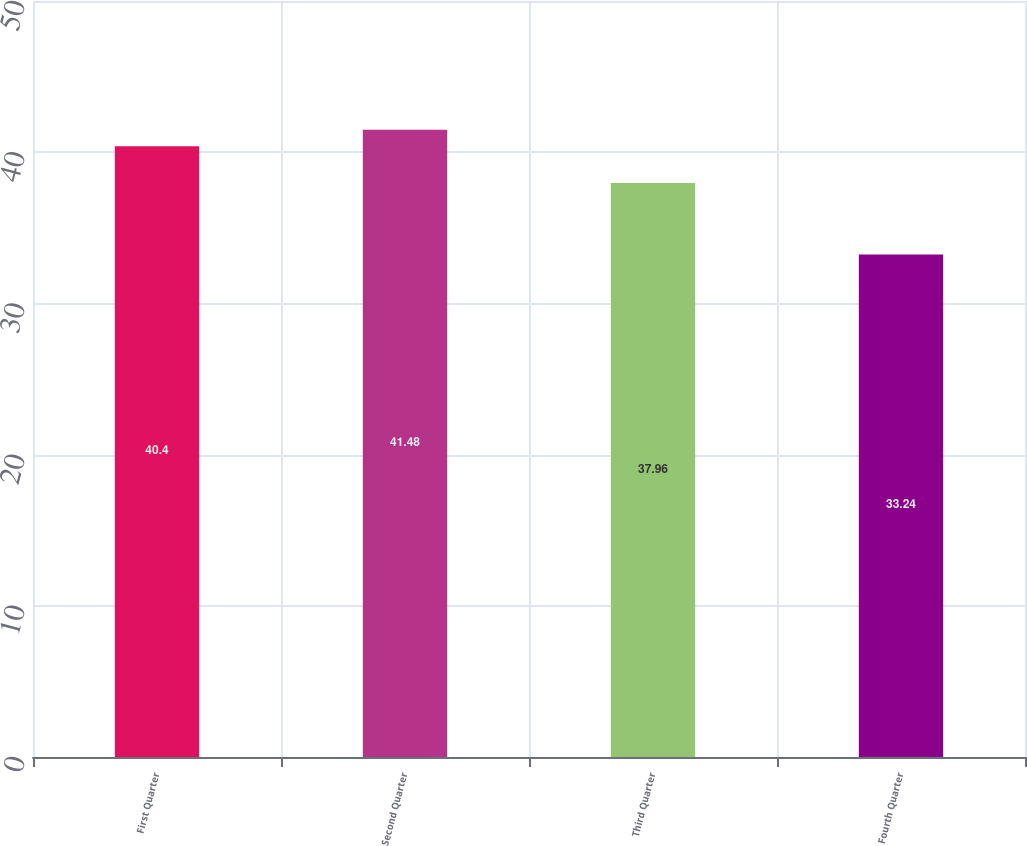<chart> <loc_0><loc_0><loc_500><loc_500><bar_chart><fcel>First Quarter<fcel>Second Quarter<fcel>Third Quarter<fcel>Fourth Quarter<nl><fcel>40.4<fcel>41.48<fcel>37.96<fcel>33.24<nl></chart> 